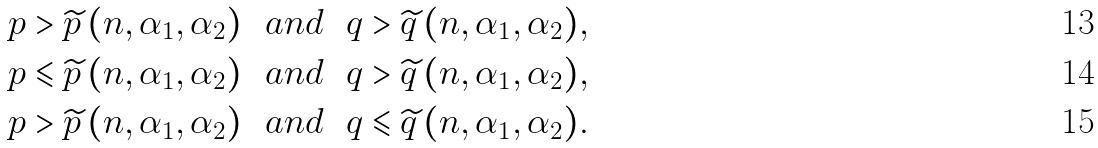<formula> <loc_0><loc_0><loc_500><loc_500>& p > \widetilde { p } \, ( n , \alpha _ { 1 } , \alpha _ { 2 } ) \ \ a n d \ \ q > \widetilde { q } \, ( n , \alpha _ { 1 } , \alpha _ { 2 } ) , \\ & p \leqslant \widetilde { p } \, ( n , \alpha _ { 1 } , \alpha _ { 2 } ) \ \ a n d \ \ q > \widetilde { q } \, ( n , \alpha _ { 1 } , \alpha _ { 2 } ) , \\ & p > \widetilde { p } \, ( n , \alpha _ { 1 } , \alpha _ { 2 } ) \ \ a n d \ \ q \leqslant \widetilde { q } \, ( n , \alpha _ { 1 } , \alpha _ { 2 } ) .</formula> 